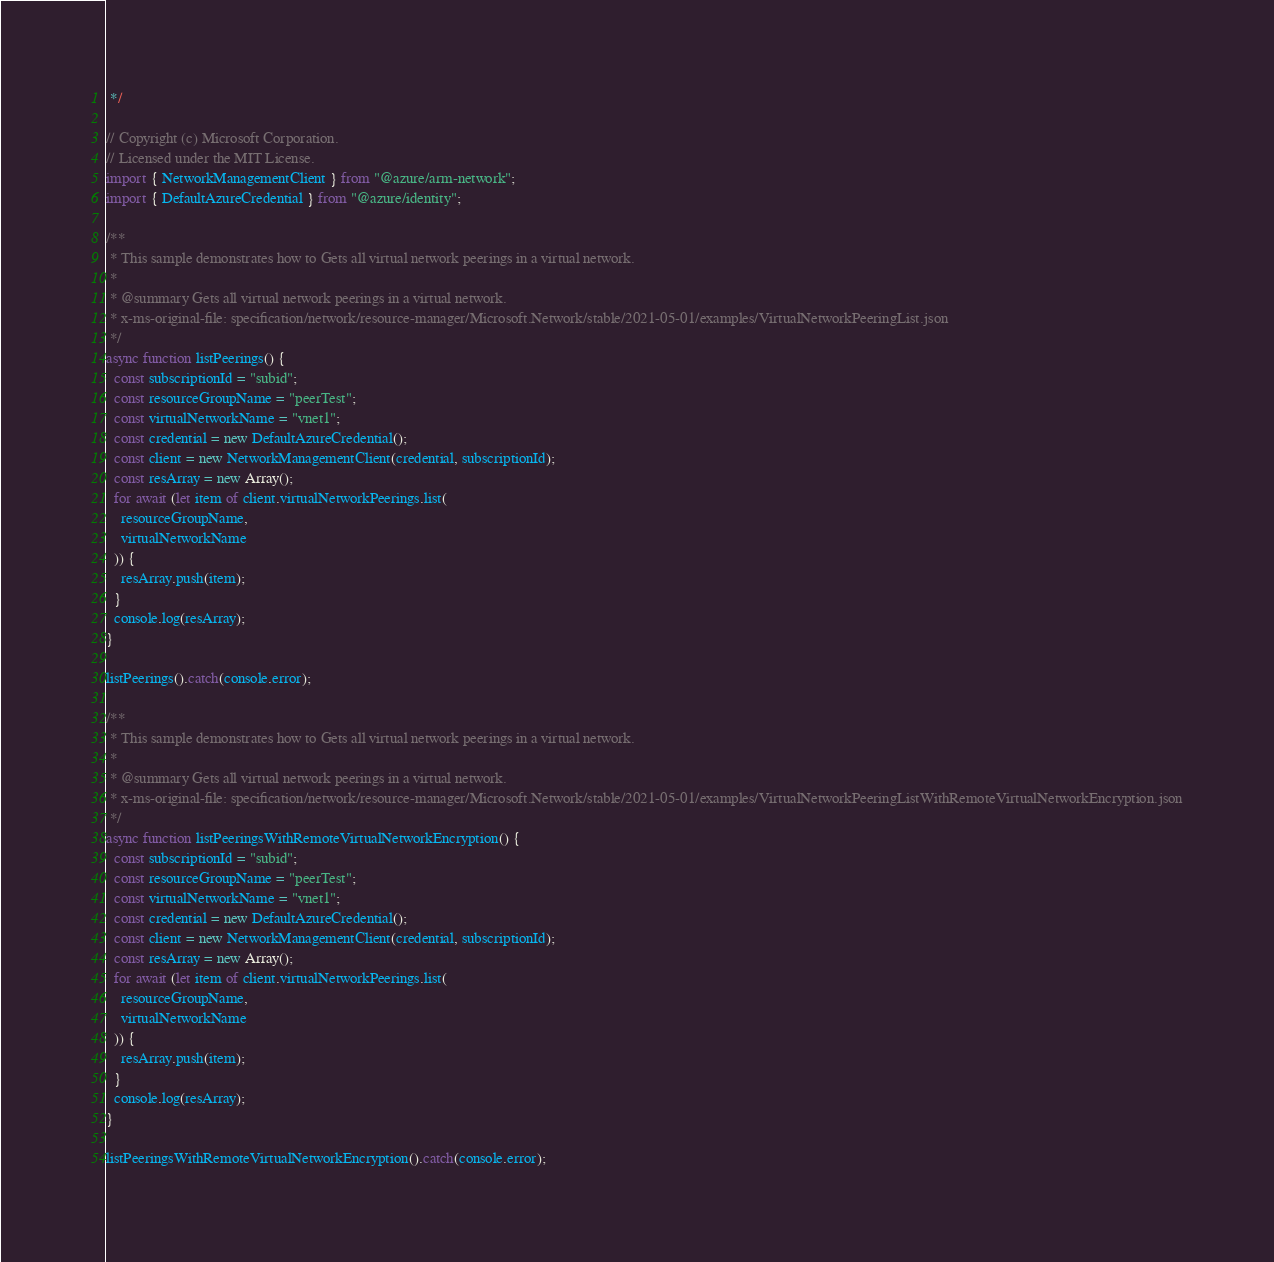<code> <loc_0><loc_0><loc_500><loc_500><_TypeScript_> */

// Copyright (c) Microsoft Corporation.
// Licensed under the MIT License.
import { NetworkManagementClient } from "@azure/arm-network";
import { DefaultAzureCredential } from "@azure/identity";

/**
 * This sample demonstrates how to Gets all virtual network peerings in a virtual network.
 *
 * @summary Gets all virtual network peerings in a virtual network.
 * x-ms-original-file: specification/network/resource-manager/Microsoft.Network/stable/2021-05-01/examples/VirtualNetworkPeeringList.json
 */
async function listPeerings() {
  const subscriptionId = "subid";
  const resourceGroupName = "peerTest";
  const virtualNetworkName = "vnet1";
  const credential = new DefaultAzureCredential();
  const client = new NetworkManagementClient(credential, subscriptionId);
  const resArray = new Array();
  for await (let item of client.virtualNetworkPeerings.list(
    resourceGroupName,
    virtualNetworkName
  )) {
    resArray.push(item);
  }
  console.log(resArray);
}

listPeerings().catch(console.error);

/**
 * This sample demonstrates how to Gets all virtual network peerings in a virtual network.
 *
 * @summary Gets all virtual network peerings in a virtual network.
 * x-ms-original-file: specification/network/resource-manager/Microsoft.Network/stable/2021-05-01/examples/VirtualNetworkPeeringListWithRemoteVirtualNetworkEncryption.json
 */
async function listPeeringsWithRemoteVirtualNetworkEncryption() {
  const subscriptionId = "subid";
  const resourceGroupName = "peerTest";
  const virtualNetworkName = "vnet1";
  const credential = new DefaultAzureCredential();
  const client = new NetworkManagementClient(credential, subscriptionId);
  const resArray = new Array();
  for await (let item of client.virtualNetworkPeerings.list(
    resourceGroupName,
    virtualNetworkName
  )) {
    resArray.push(item);
  }
  console.log(resArray);
}

listPeeringsWithRemoteVirtualNetworkEncryption().catch(console.error);
</code> 